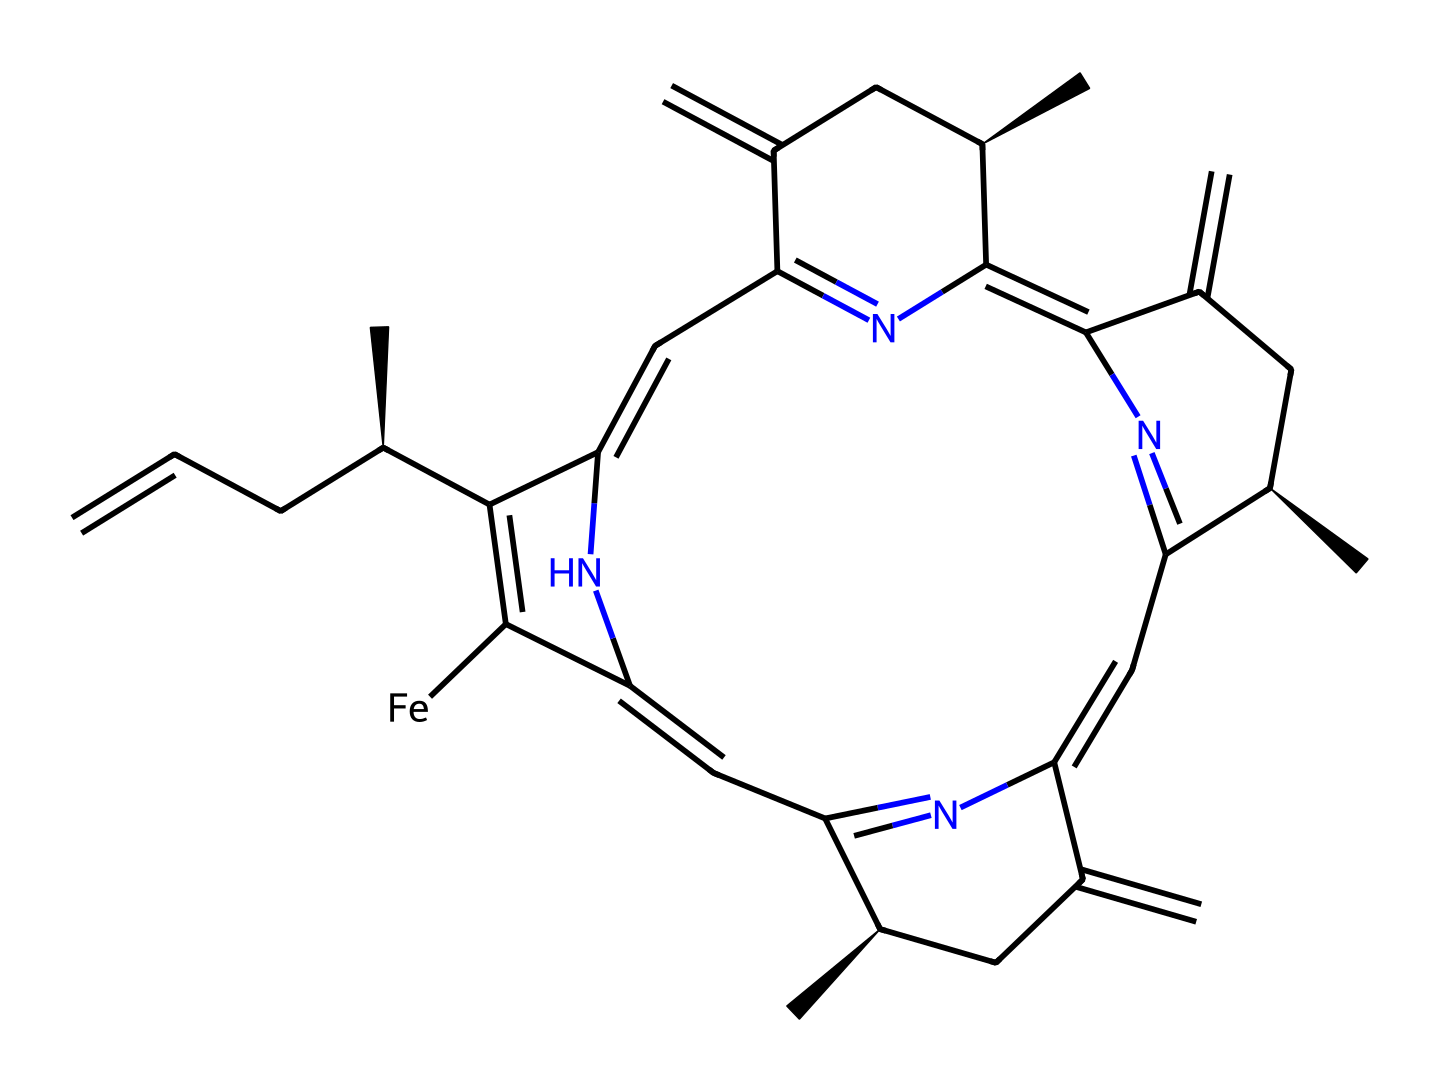What is the central metal atom in this coordination complex? The provided SMILES representation indicates the presence of an iron atom, which can be identified as the central atom typically found in hemoglobin complexes.
Answer: iron How many nitrogen atoms are present in the chemical structure? By analyzing the SMILES, we count a total of 6 nitrogen atoms indicated by "N" throughout the structure.
Answer: 6 What type of coordination compound is this? The chemical structure represents a heme group, which is a type of coordination compound crucial for oxygen transport, as seen in hemoglobin.
Answer: heme Does this compound likely have a paramagnetic property? The presence of an unpaired electron in the d-orbitals of the iron atom indicates that this coordination compound is likely to be paramagnetic.
Answer: yes How many fused rings can be identified in this structure? By examining the structure, there are four fused ring systems that can be identified, characteristic of porphyrin-like structures.
Answer: 4 What role does this coordination complex play in the body? This coordination complex facilitates the transport of oxygen from the lungs to tissues, playing a vital role in respiration.
Answer: oxygen transport 